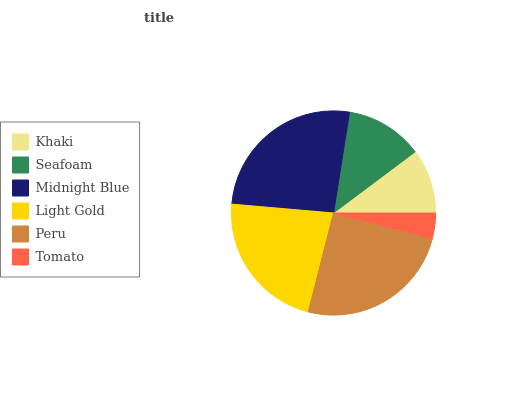Is Tomato the minimum?
Answer yes or no. Yes. Is Midnight Blue the maximum?
Answer yes or no. Yes. Is Seafoam the minimum?
Answer yes or no. No. Is Seafoam the maximum?
Answer yes or no. No. Is Seafoam greater than Khaki?
Answer yes or no. Yes. Is Khaki less than Seafoam?
Answer yes or no. Yes. Is Khaki greater than Seafoam?
Answer yes or no. No. Is Seafoam less than Khaki?
Answer yes or no. No. Is Light Gold the high median?
Answer yes or no. Yes. Is Seafoam the low median?
Answer yes or no. Yes. Is Khaki the high median?
Answer yes or no. No. Is Midnight Blue the low median?
Answer yes or no. No. 